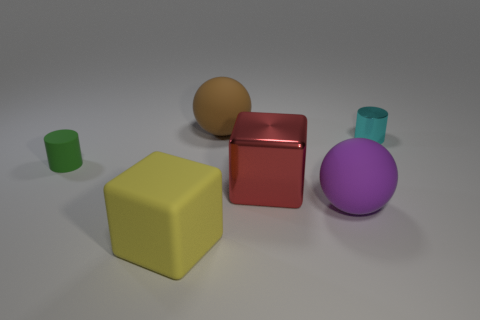Add 2 small red rubber objects. How many objects exist? 8 Subtract all cylinders. How many objects are left? 4 Add 6 large purple objects. How many large purple objects exist? 7 Subtract 1 cyan cylinders. How many objects are left? 5 Subtract all large gray rubber cylinders. Subtract all cyan metal cylinders. How many objects are left? 5 Add 2 metal cylinders. How many metal cylinders are left? 3 